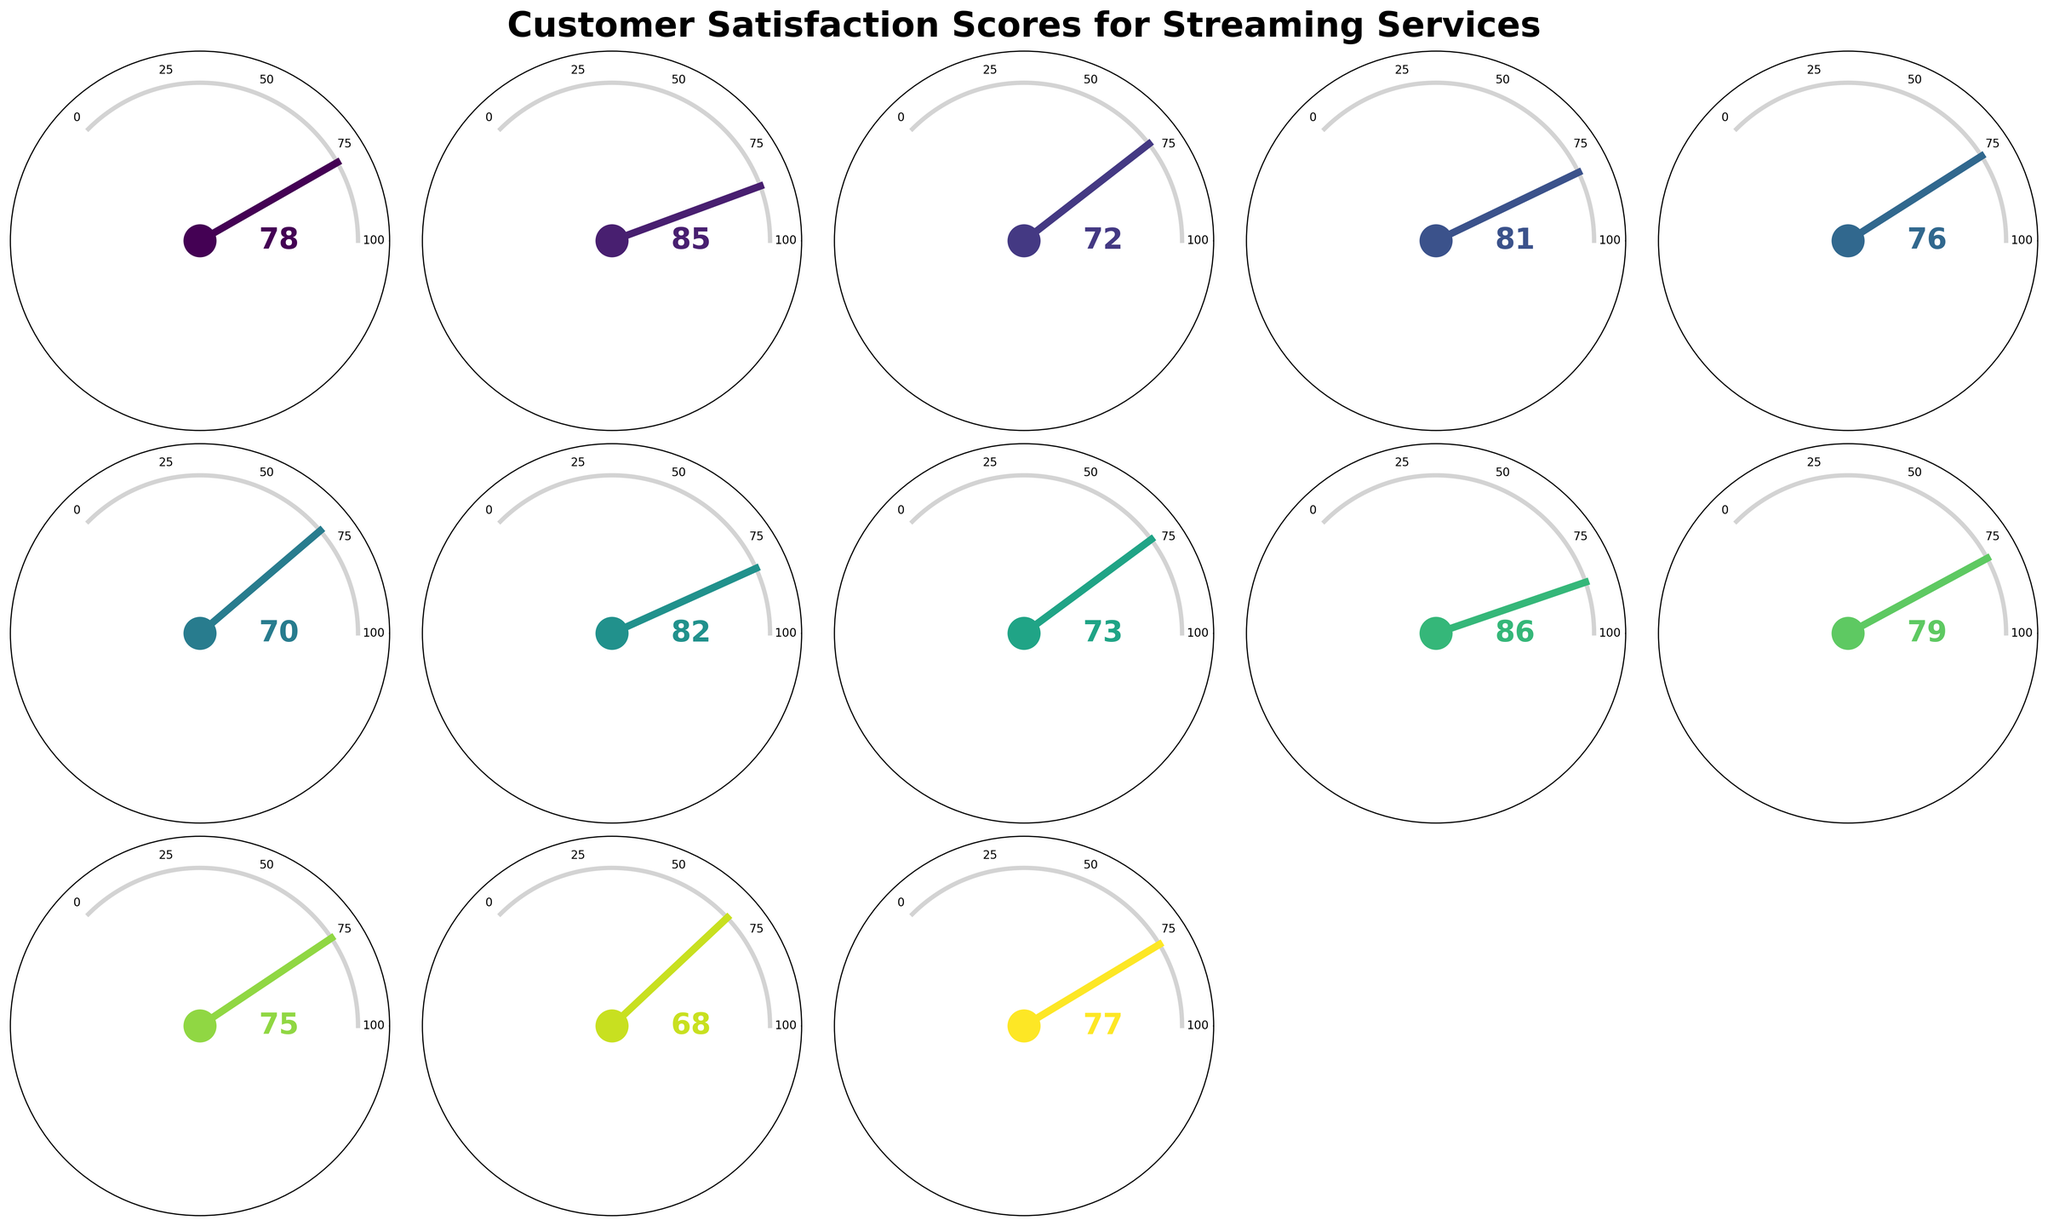What is the customer satisfaction score for Amazon Prime Video's Prime tier? Look at the gauge chart for Amazon Prime Video, specifically finding the pointer and check its score.
Answer: 76 Which streaming service and tier has the highest customer satisfaction score? Identify which gauge chart has the highest pointer angle indicating a score near 100, then note the service and tier.
Answer: HBO Max Ad-free What is the difference in satisfaction scores between Disney+ Basic and Disney+ Premium? Check the satisfaction scores for Disney+ in both Basic and Premium tiers, then calculate the difference (Premium - Basic).
Answer: 9 Which has a higher satisfaction score: Hulu's Ad-supported tier or YouTube Premium's Individual tier? Compare the satisfaction scores from the gauge charts for Hulu Ad-supported and YouTube Premium Individual.
Answer: YouTube Premium Individual What is the average satisfaction score for all streaming services' premium tiers? Identify all Premium tier satisfaction scores (Netflix Premium, Disney+ Premium, etc.), sum them, and divide by the number of Premium tiers.
Answer: (85 + 81 + 82 + 86 + 77) / 5 = 82.2 Among Apple TV+ Standard and Netflix Standard, which has a higher satisfaction score? Compare the satisfaction scores between Apple TV+ Standard and Netflix Standard from their respective gauge charts.
Answer: Netflix Standard How many streaming services have a satisfaction score of 80 or higher across any of their tiers? Count the number of gauge charts with satisfaction scores equal to or above 80, focusing on any tier of the service.
Answer: 6 What is the combined satisfaction score for all tiers of Hulu and HBO Max? Sum the satisfaction scores for Hulu Ad-supported, Hulu No Ads, HBO Max Ad-supported, and HBO Max Ad-free.
Answer: 70 + 82 + 73 + 86 = 311 